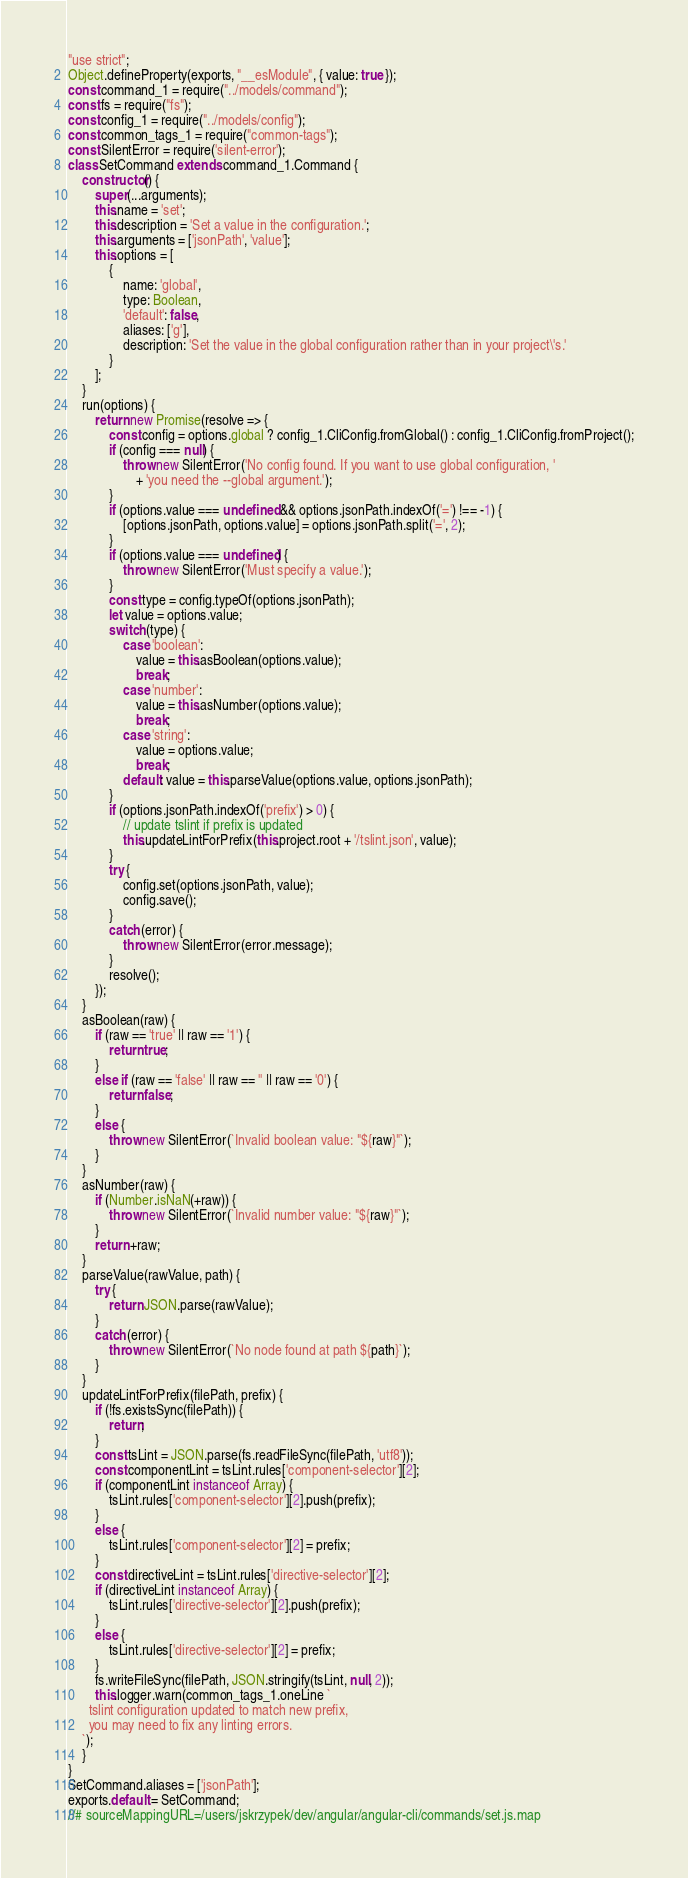Convert code to text. <code><loc_0><loc_0><loc_500><loc_500><_JavaScript_>"use strict";
Object.defineProperty(exports, "__esModule", { value: true });
const command_1 = require("../models/command");
const fs = require("fs");
const config_1 = require("../models/config");
const common_tags_1 = require("common-tags");
const SilentError = require('silent-error');
class SetCommand extends command_1.Command {
    constructor() {
        super(...arguments);
        this.name = 'set';
        this.description = 'Set a value in the configuration.';
        this.arguments = ['jsonPath', 'value'];
        this.options = [
            {
                name: 'global',
                type: Boolean,
                'default': false,
                aliases: ['g'],
                description: 'Set the value in the global configuration rather than in your project\'s.'
            }
        ];
    }
    run(options) {
        return new Promise(resolve => {
            const config = options.global ? config_1.CliConfig.fromGlobal() : config_1.CliConfig.fromProject();
            if (config === null) {
                throw new SilentError('No config found. If you want to use global configuration, '
                    + 'you need the --global argument.');
            }
            if (options.value === undefined && options.jsonPath.indexOf('=') !== -1) {
                [options.jsonPath, options.value] = options.jsonPath.split('=', 2);
            }
            if (options.value === undefined) {
                throw new SilentError('Must specify a value.');
            }
            const type = config.typeOf(options.jsonPath);
            let value = options.value;
            switch (type) {
                case 'boolean':
                    value = this.asBoolean(options.value);
                    break;
                case 'number':
                    value = this.asNumber(options.value);
                    break;
                case 'string':
                    value = options.value;
                    break;
                default: value = this.parseValue(options.value, options.jsonPath);
            }
            if (options.jsonPath.indexOf('prefix') > 0) {
                // update tslint if prefix is updated
                this.updateLintForPrefix(this.project.root + '/tslint.json', value);
            }
            try {
                config.set(options.jsonPath, value);
                config.save();
            }
            catch (error) {
                throw new SilentError(error.message);
            }
            resolve();
        });
    }
    asBoolean(raw) {
        if (raw == 'true' || raw == '1') {
            return true;
        }
        else if (raw == 'false' || raw == '' || raw == '0') {
            return false;
        }
        else {
            throw new SilentError(`Invalid boolean value: "${raw}"`);
        }
    }
    asNumber(raw) {
        if (Number.isNaN(+raw)) {
            throw new SilentError(`Invalid number value: "${raw}"`);
        }
        return +raw;
    }
    parseValue(rawValue, path) {
        try {
            return JSON.parse(rawValue);
        }
        catch (error) {
            throw new SilentError(`No node found at path ${path}`);
        }
    }
    updateLintForPrefix(filePath, prefix) {
        if (!fs.existsSync(filePath)) {
            return;
        }
        const tsLint = JSON.parse(fs.readFileSync(filePath, 'utf8'));
        const componentLint = tsLint.rules['component-selector'][2];
        if (componentLint instanceof Array) {
            tsLint.rules['component-selector'][2].push(prefix);
        }
        else {
            tsLint.rules['component-selector'][2] = prefix;
        }
        const directiveLint = tsLint.rules['directive-selector'][2];
        if (directiveLint instanceof Array) {
            tsLint.rules['directive-selector'][2].push(prefix);
        }
        else {
            tsLint.rules['directive-selector'][2] = prefix;
        }
        fs.writeFileSync(filePath, JSON.stringify(tsLint, null, 2));
        this.logger.warn(common_tags_1.oneLine `
      tslint configuration updated to match new prefix,
      you may need to fix any linting errors.
    `);
    }
}
SetCommand.aliases = ['jsonPath'];
exports.default = SetCommand;
//# sourceMappingURL=/users/jskrzypek/dev/angular/angular-cli/commands/set.js.map</code> 